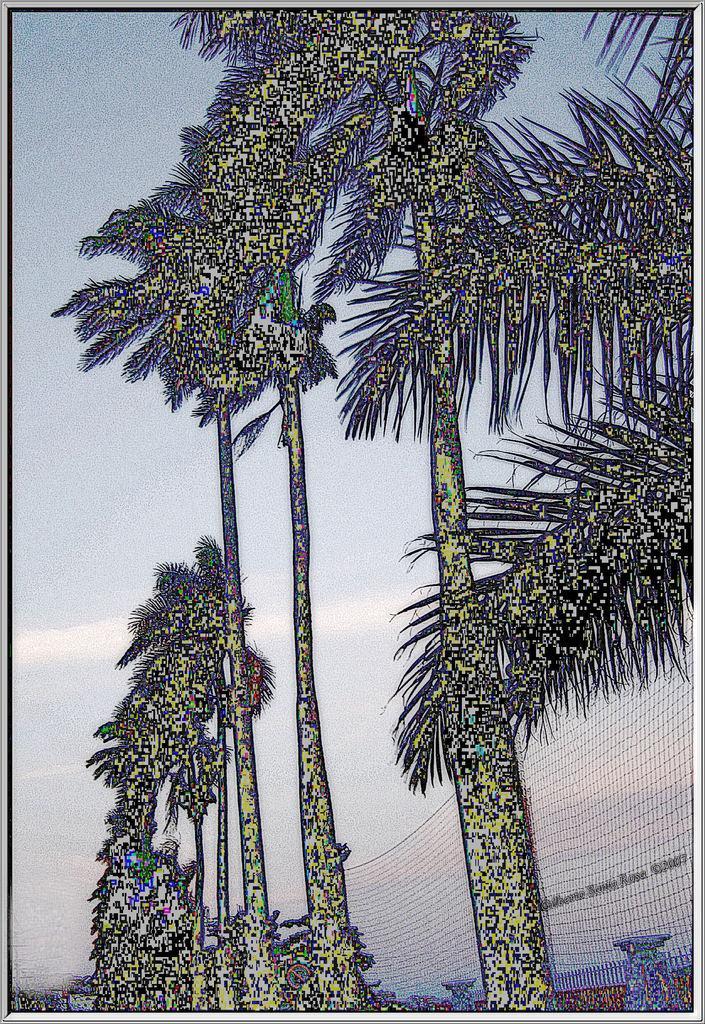In one or two sentences, can you explain what this image depicts? It is an edited image. In this image we can see the trees and also the fence. In the background we can see the sky with some clouds and the image has borders. 